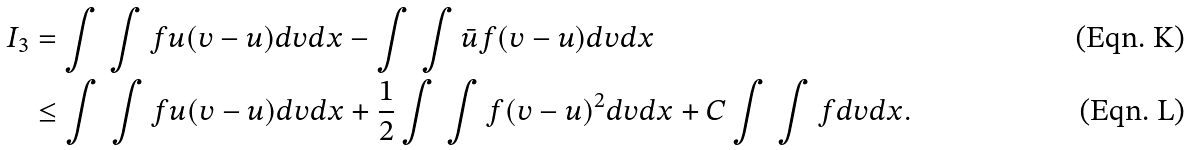Convert formula to latex. <formula><loc_0><loc_0><loc_500><loc_500>I _ { 3 } & = \int \, \int f u ( v - u ) d v d x - \int \, \int \bar { u } f ( v - u ) d v d x \\ & \leq \int \, \int f u ( v - u ) d v d x + \frac { 1 } { 2 } \int \, \int f ( v - u ) ^ { 2 } d v d x + C \int \, \int f d v d x .</formula> 